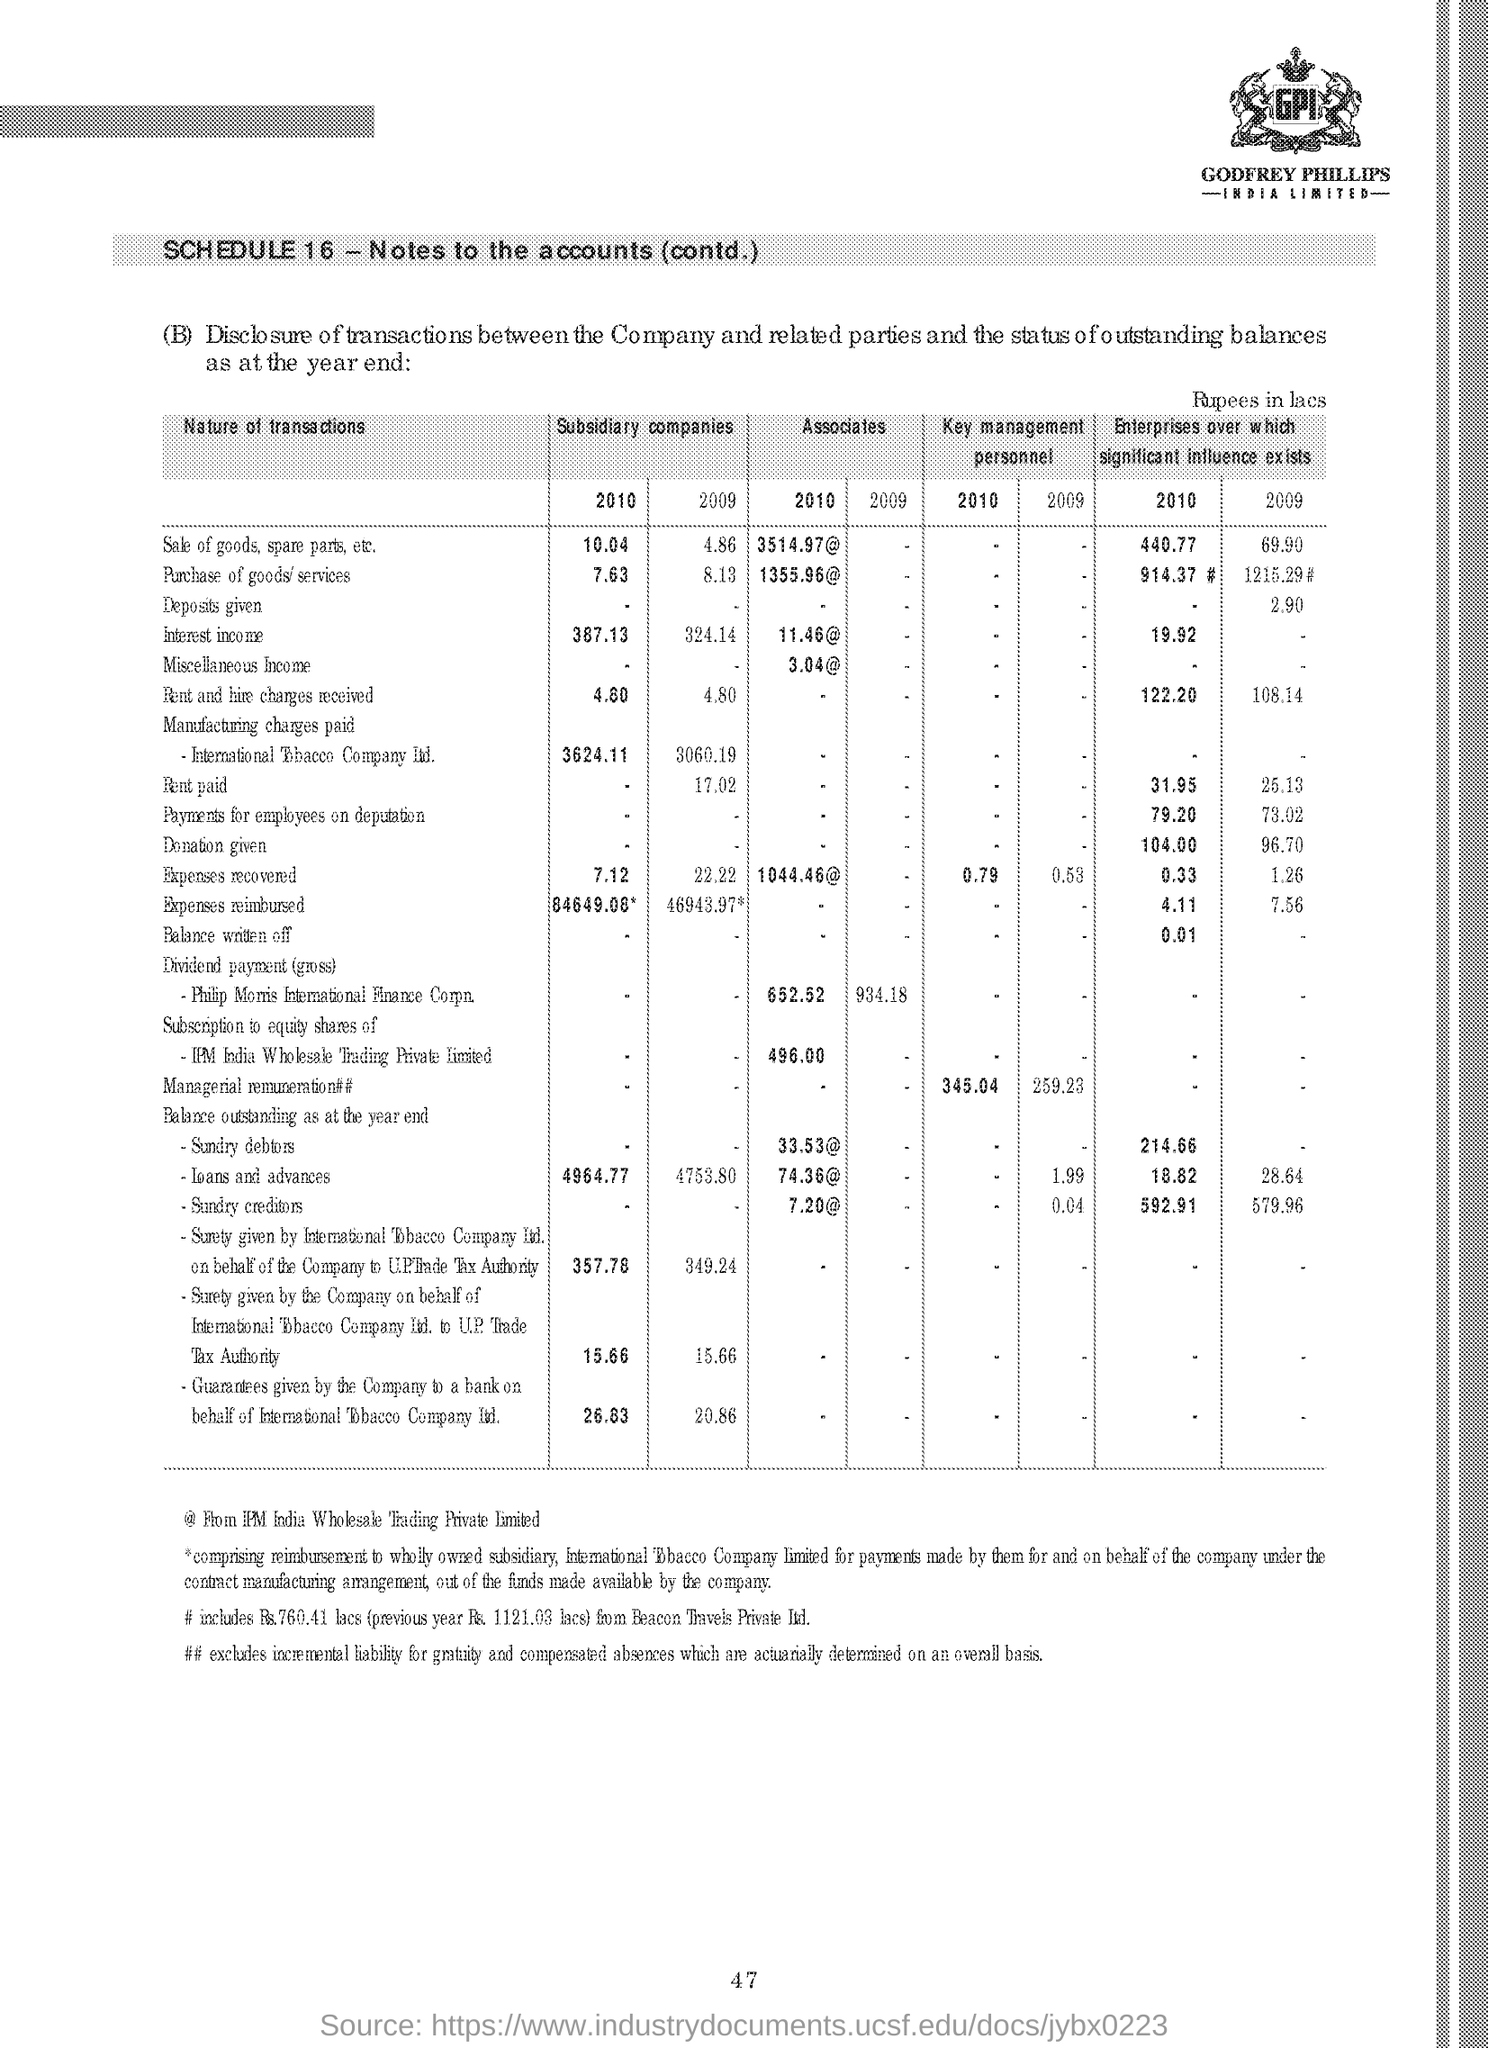What is schedule 16?
Your answer should be very brief. Notes to the accounts. How much is the sale of goods, spare parts, etc of subsidiary companies in 2010?
Offer a very short reply. 10.04. What is the heading of first column?
Your answer should be compact. NATURE OF TRANSACTIONS. What does @ refer to?
Make the answer very short. From ipm india wholesale trading private limited. Which companies logo is printed at the top right corner?
Keep it short and to the point. GODFREY PHILIPS  INDIA LIMITED. 